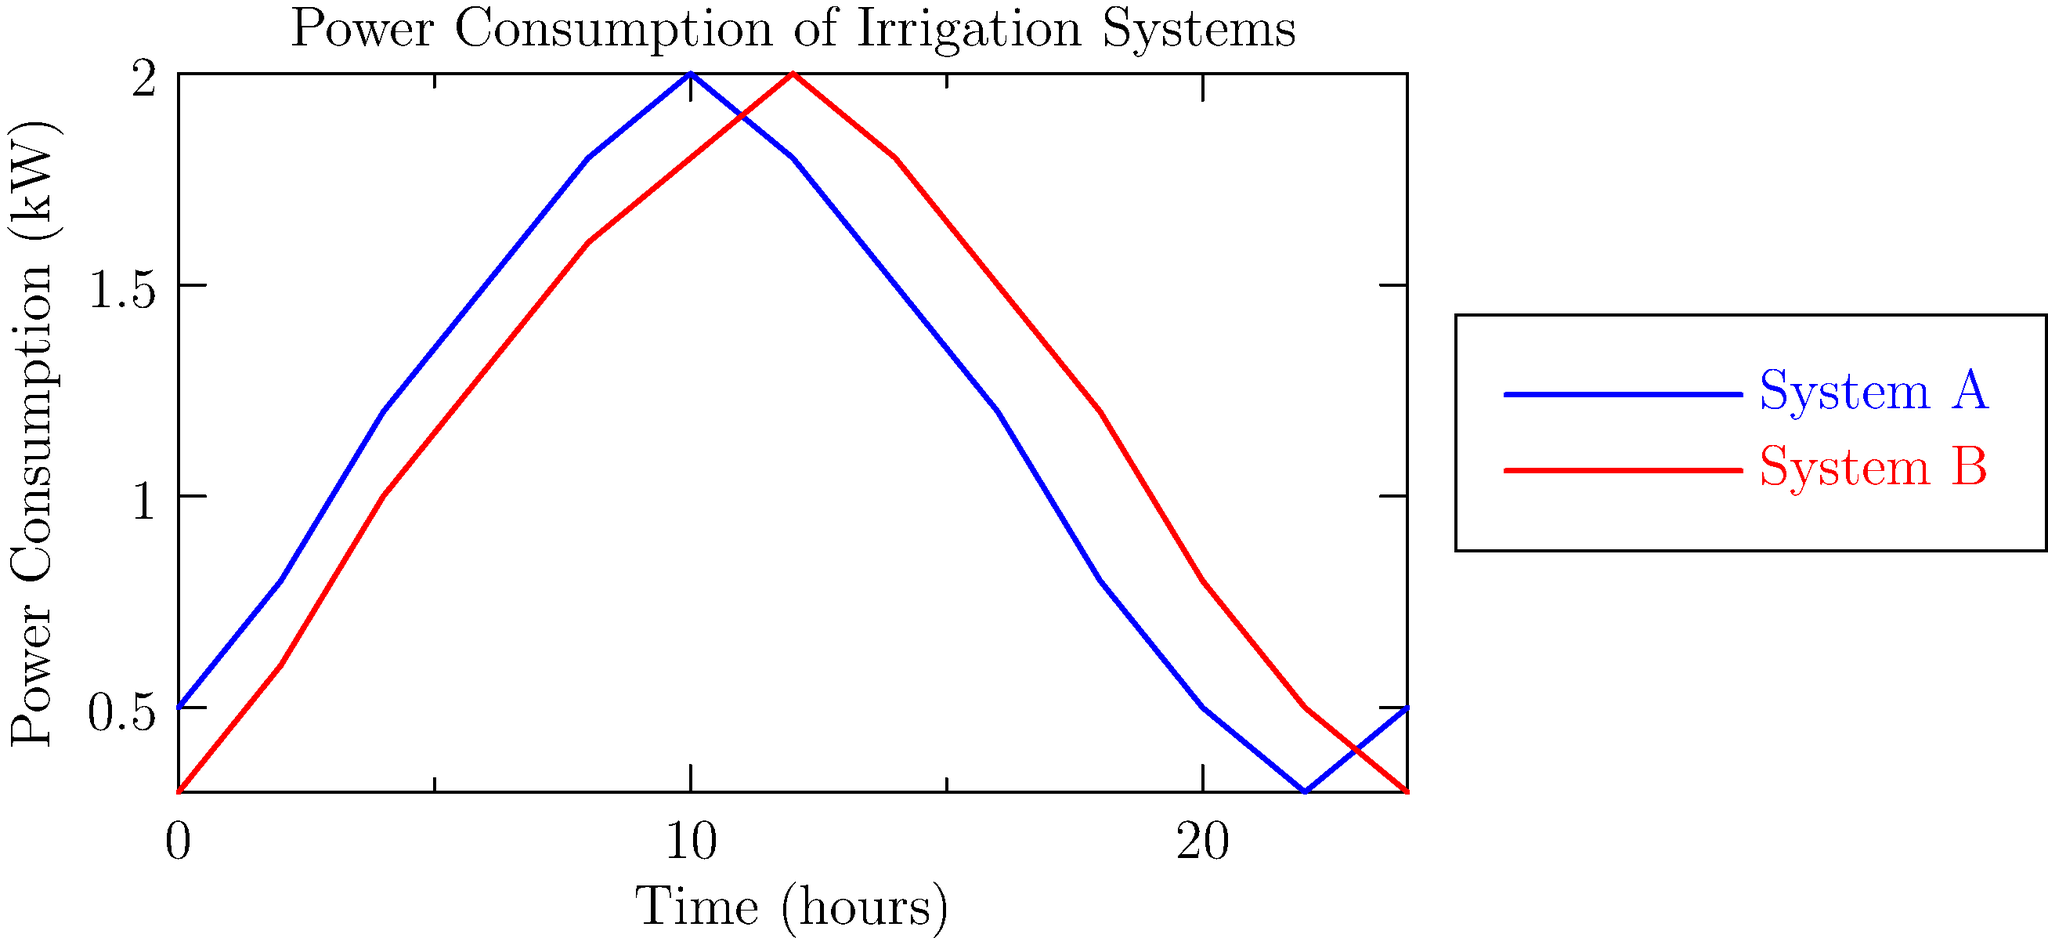As a plant breeder working with barley and wheat, you're analyzing power consumption data for two automated irrigation systems. The graph shows the power consumption patterns over a 24-hour period for System A and System B. Which system would you recommend for irrigating a large barley field, considering that barley typically requires more water during the day and less at night? To answer this question, let's analyze the power consumption patterns of both systems:

1. System A (blue line):
   - Peak power consumption: ~2.0 kW around 12 hours (noon)
   - Lower power consumption: ~0.3-0.5 kW during night hours (22-24 and 0-2)

2. System B (red line):
   - Peak power consumption: ~2.0 kW around 14 hours (2 PM)
   - Lower power consumption: ~0.3-0.6 kW during night hours (22-24 and 0-2)

3. Barley water requirements:
   - Barley needs more water during the day and less at night

4. Comparison:
   - System A has higher power consumption during daylight hours (6-18)
   - System B has slightly lower power consumption during most daylight hours but maintains higher consumption in the late afternoon

5. Interpretation:
   - Higher power consumption likely correlates with higher water output
   - System A's power consumption pattern better matches barley's water requirements

6. Conclusion:
   System A is more suitable for irrigating a large barley field because its power consumption (and likely water output) is higher during daylight hours when barley requires more water, and lower at night when less water is needed.
Answer: System A 